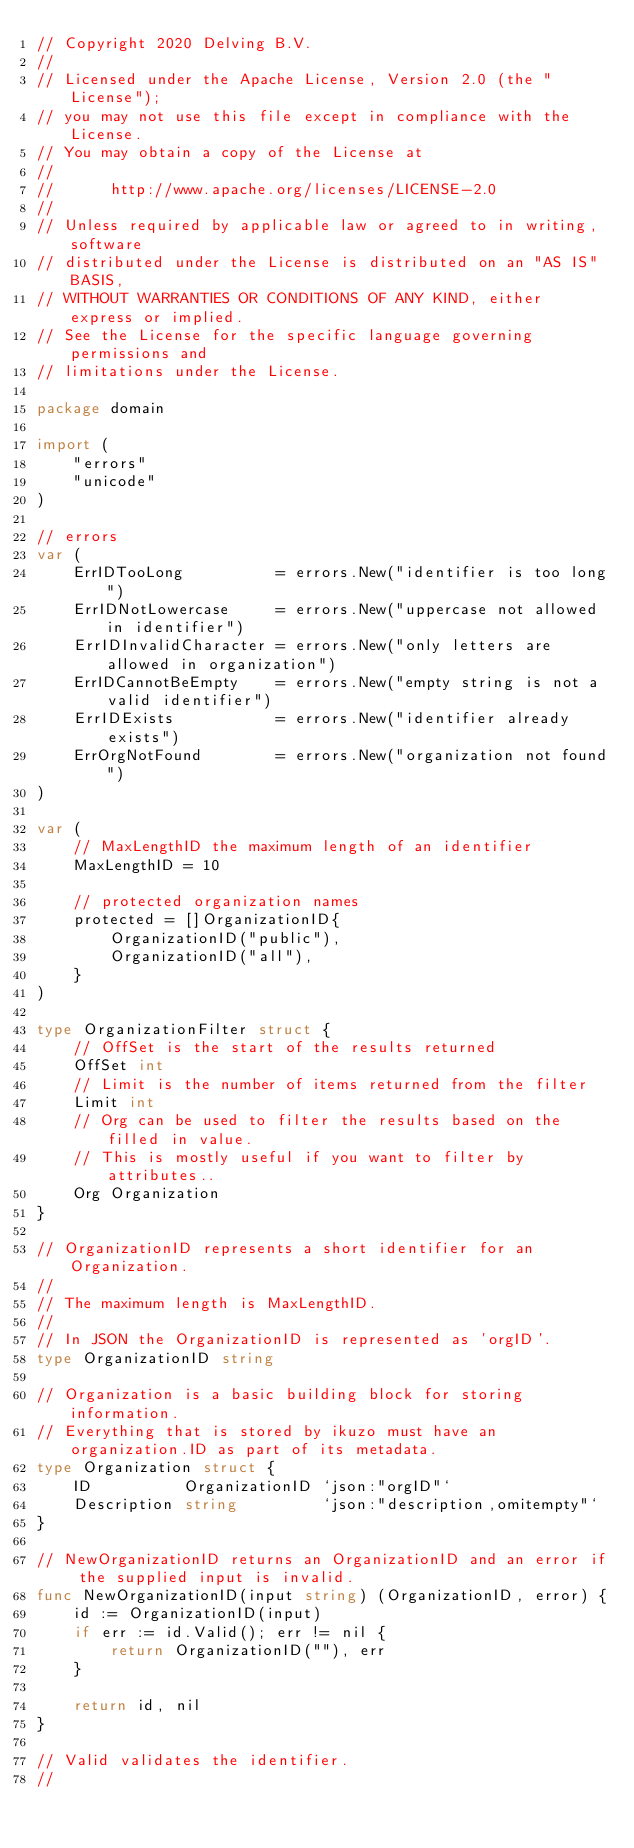Convert code to text. <code><loc_0><loc_0><loc_500><loc_500><_Go_>// Copyright 2020 Delving B.V.
//
// Licensed under the Apache License, Version 2.0 (the "License");
// you may not use this file except in compliance with the License.
// You may obtain a copy of the License at
//
//      http://www.apache.org/licenses/LICENSE-2.0
//
// Unless required by applicable law or agreed to in writing, software
// distributed under the License is distributed on an "AS IS" BASIS,
// WITHOUT WARRANTIES OR CONDITIONS OF ANY KIND, either express or implied.
// See the License for the specific language governing permissions and
// limitations under the License.

package domain

import (
	"errors"
	"unicode"
)

// errors
var (
	ErrIDTooLong          = errors.New("identifier is too long")
	ErrIDNotLowercase     = errors.New("uppercase not allowed in identifier")
	ErrIDInvalidCharacter = errors.New("only letters are allowed in organization")
	ErrIDCannotBeEmpty    = errors.New("empty string is not a valid identifier")
	ErrIDExists           = errors.New("identifier already exists")
	ErrOrgNotFound        = errors.New("organization not found")
)

var (
	// MaxLengthID the maximum length of an identifier
	MaxLengthID = 10

	// protected organization names
	protected = []OrganizationID{
		OrganizationID("public"),
		OrganizationID("all"),
	}
)

type OrganizationFilter struct {
	// OffSet is the start of the results returned
	OffSet int
	// Limit is the number of items returned from the filter
	Limit int
	// Org can be used to filter the results based on the filled in value.
	// This is mostly useful if you want to filter by attributes..
	Org Organization
}

// OrganizationID represents a short identifier for an Organization.
//
// The maximum length is MaxLengthID.
//
// In JSON the OrganizationID is represented as 'orgID'.
type OrganizationID string

// Organization is a basic building block for storing information.
// Everything that is stored by ikuzo must have an organization.ID as part of its metadata.
type Organization struct {
	ID          OrganizationID `json:"orgID"`
	Description string         `json:"description,omitempty"`
}

// NewOrganizationID returns an OrganizationID and an error if the supplied input is invalid.
func NewOrganizationID(input string) (OrganizationID, error) {
	id := OrganizationID(input)
	if err := id.Valid(); err != nil {
		return OrganizationID(""), err
	}

	return id, nil
}

// Valid validates the identifier.
//</code> 